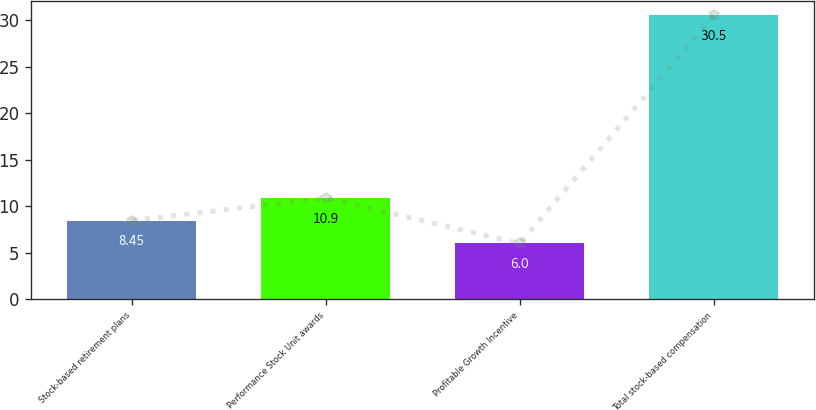Convert chart. <chart><loc_0><loc_0><loc_500><loc_500><bar_chart><fcel>Stock-based retirement plans<fcel>Performance Stock Unit awards<fcel>Profitable Growth Incentive<fcel>Total stock-based compensation<nl><fcel>8.45<fcel>10.9<fcel>6<fcel>30.5<nl></chart> 